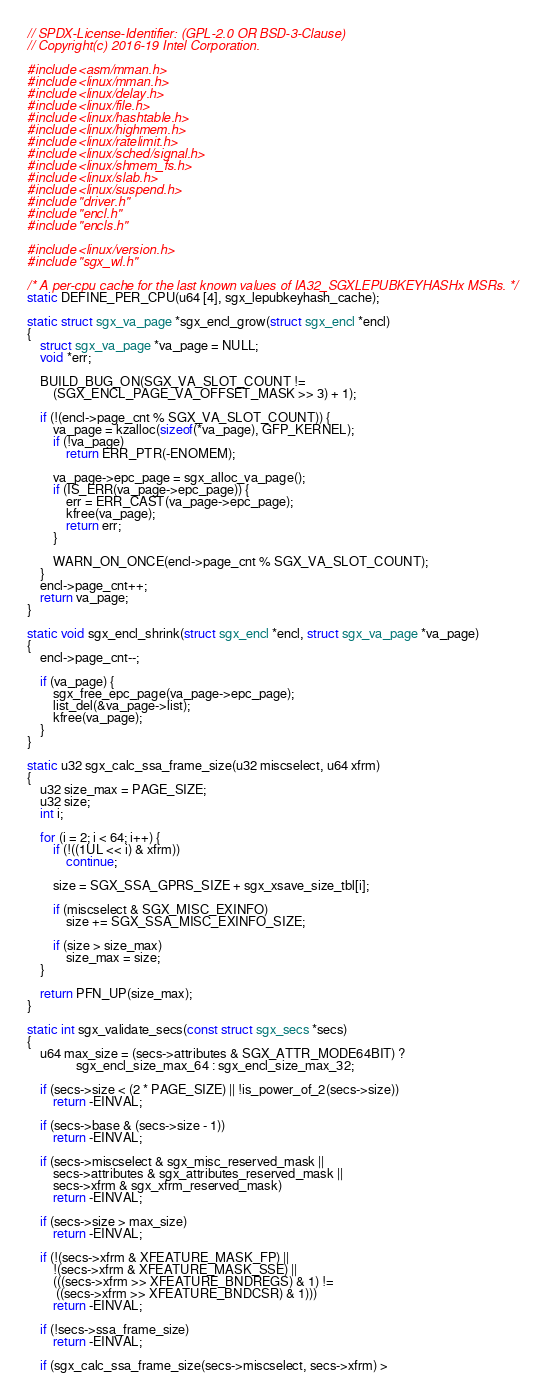<code> <loc_0><loc_0><loc_500><loc_500><_C_>// SPDX-License-Identifier: (GPL-2.0 OR BSD-3-Clause)
// Copyright(c) 2016-19 Intel Corporation.

#include <asm/mman.h>
#include <linux/mman.h>
#include <linux/delay.h>
#include <linux/file.h>
#include <linux/hashtable.h>
#include <linux/highmem.h>
#include <linux/ratelimit.h>
#include <linux/sched/signal.h>
#include <linux/shmem_fs.h>
#include <linux/slab.h>
#include <linux/suspend.h>
#include "driver.h"
#include "encl.h"
#include "encls.h"

#include <linux/version.h>
#include "sgx_wl.h"

/* A per-cpu cache for the last known values of IA32_SGXLEPUBKEYHASHx MSRs. */
static DEFINE_PER_CPU(u64 [4], sgx_lepubkeyhash_cache);

static struct sgx_va_page *sgx_encl_grow(struct sgx_encl *encl)
{
	struct sgx_va_page *va_page = NULL;
	void *err;

	BUILD_BUG_ON(SGX_VA_SLOT_COUNT !=
		(SGX_ENCL_PAGE_VA_OFFSET_MASK >> 3) + 1);

	if (!(encl->page_cnt % SGX_VA_SLOT_COUNT)) {
		va_page = kzalloc(sizeof(*va_page), GFP_KERNEL);
		if (!va_page)
			return ERR_PTR(-ENOMEM);

		va_page->epc_page = sgx_alloc_va_page();
		if (IS_ERR(va_page->epc_page)) {
			err = ERR_CAST(va_page->epc_page);
			kfree(va_page);
			return err;
		}

		WARN_ON_ONCE(encl->page_cnt % SGX_VA_SLOT_COUNT);
	}
	encl->page_cnt++;
	return va_page;
}

static void sgx_encl_shrink(struct sgx_encl *encl, struct sgx_va_page *va_page)
{
	encl->page_cnt--;

	if (va_page) {
		sgx_free_epc_page(va_page->epc_page);
		list_del(&va_page->list);
		kfree(va_page);
	}
}

static u32 sgx_calc_ssa_frame_size(u32 miscselect, u64 xfrm)
{
	u32 size_max = PAGE_SIZE;
	u32 size;
	int i;

	for (i = 2; i < 64; i++) {
		if (!((1UL << i) & xfrm))
			continue;

		size = SGX_SSA_GPRS_SIZE + sgx_xsave_size_tbl[i];

		if (miscselect & SGX_MISC_EXINFO)
			size += SGX_SSA_MISC_EXINFO_SIZE;

		if (size > size_max)
			size_max = size;
	}

	return PFN_UP(size_max);
}

static int sgx_validate_secs(const struct sgx_secs *secs)
{
	u64 max_size = (secs->attributes & SGX_ATTR_MODE64BIT) ?
		       sgx_encl_size_max_64 : sgx_encl_size_max_32;

	if (secs->size < (2 * PAGE_SIZE) || !is_power_of_2(secs->size))
		return -EINVAL;

	if (secs->base & (secs->size - 1))
		return -EINVAL;

	if (secs->miscselect & sgx_misc_reserved_mask ||
	    secs->attributes & sgx_attributes_reserved_mask ||
	    secs->xfrm & sgx_xfrm_reserved_mask)
		return -EINVAL;

	if (secs->size > max_size)
		return -EINVAL;

	if (!(secs->xfrm & XFEATURE_MASK_FP) ||
	    !(secs->xfrm & XFEATURE_MASK_SSE) ||
	    (((secs->xfrm >> XFEATURE_BNDREGS) & 1) !=
	     ((secs->xfrm >> XFEATURE_BNDCSR) & 1)))
		return -EINVAL;

	if (!secs->ssa_frame_size)
		return -EINVAL;

	if (sgx_calc_ssa_frame_size(secs->miscselect, secs->xfrm) ></code> 